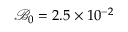<formula> <loc_0><loc_0><loc_500><loc_500>\mathcal { B } _ { 0 } = 2 . 5 \times 1 0 ^ { - 2 }</formula> 